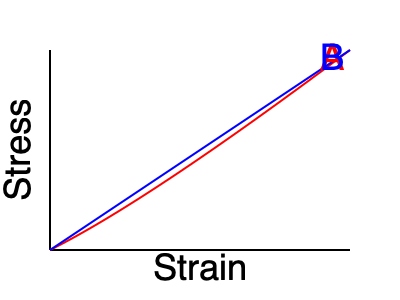The stress-strain curves for two different materials used in tennis racket strings are shown above. Which material (A or B) would be more suitable for a player seeking better control and less power in their shots, and why? To answer this question, we need to analyze the stress-strain curves and their implications for tennis racket string performance:

1. Curve A (red) shows a non-linear relationship between stress and strain. This curve is typical for elastic materials like natural gut or multifilament strings.
2. Curve B (blue) shows a more linear relationship between stress and strain. This curve is typical for stiffer materials like polyester strings.

3. For better control and less power:
   a) We want less energy return from the strings, which means less elastic deformation.
   b) We also want more predictable behavior under different loads.

4. Analyzing the curves:
   a) Material A stores more energy when stretched (area under the curve is larger) and returns more of this energy upon release, resulting in more power.
   b) Material B has a more consistent response across different loads (linear relationship), providing more predictable behavior.
   c) Material B deforms less under the same stress, indicating it's stiffer and will transfer more of the ball's incoming energy back to it, rather than absorbing and returning it.

5. In tennis terms:
   a) Material A would provide more "trampoline effect," generating more power but potentially less control.
   b) Material B would provide a more "solid" feel, less power, and potentially more control due to its predictable response.

Therefore, Material B would be more suitable for a player seeking better control and less power in their shots.
Answer: Material B, due to its stiffer, more linear stress-strain relationship providing less energy return and more predictable behavior. 